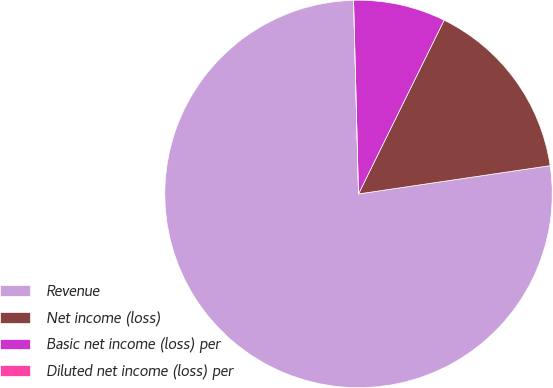<chart> <loc_0><loc_0><loc_500><loc_500><pie_chart><fcel>Revenue<fcel>Net income (loss)<fcel>Basic net income (loss) per<fcel>Diluted net income (loss) per<nl><fcel>76.92%<fcel>15.38%<fcel>7.69%<fcel>0.0%<nl></chart> 